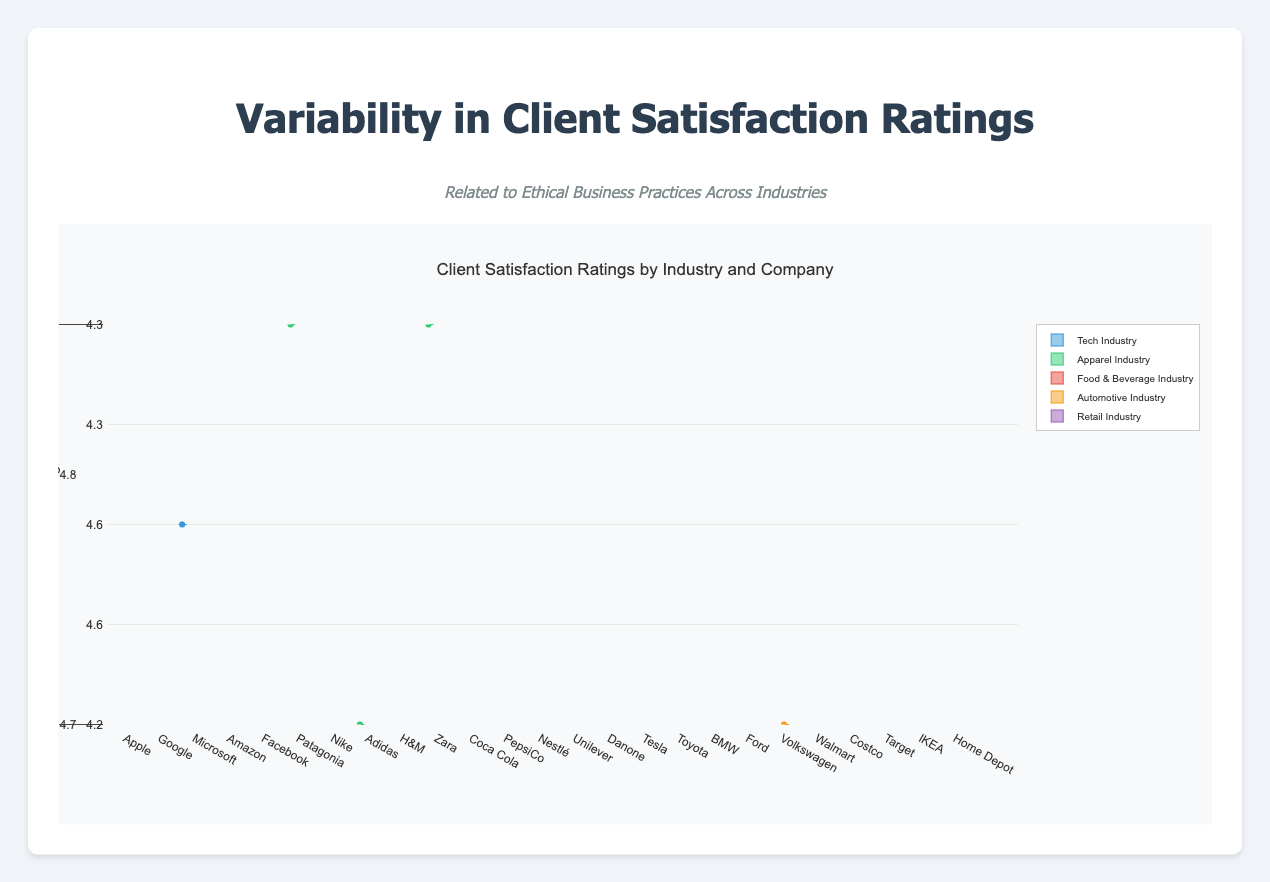What is the title of the plot? The title of the plot is located at the top and indicates the main subject of the visualization.
Answer: Client Satisfaction Ratings by Industry and Company Which industry has the highest median client satisfaction rating? To determine which industry has the highest median, look at the median line (middle line) in the boxes and compare the medians across industries.
Answer: Tech Industry Which company in the Tech Industry has the most consistent client satisfaction ratings? Consistency can be assessed by the spread, or interquartile range (IQR), of the boxplot. The company with the smallest IQR has the most consistent ratings.
Answer: Apple Compare the median satisfaction ratings between Tesla and Toyota in the Automotive Industry. Identify the median line within the boxes of Tesla and Toyota. Compare which line is higher on the satisfaction rating axis.
Answer: Tesla has a higher median satisfaction rating than Toyota Which company in the Food & Beverage Industry shows the highest client satisfaction ratings? Look for the tallest median line within the Food & Beverage Industry's box plots.
Answer: Danone What is the range of satisfaction ratings for Patagonia in the Apparel Industry? The range is the difference between the maximum and minimum values represented by the whiskers of Patagonia's box plot.
Answer: 4.7 to 4.9 Which industry shows the greatest variability in client satisfaction ratings? Variability can be assessed by comparing the overall height of the whiskers (the range from minimum to maximum) across industries.
Answer: Retail Industry What is the interquartile range (IQR) for Amazon in the Tech Industry? The IQR is the difference between the 75th percentile (upper edge of the box) and the 25th percentile (lower edge of the box). Identify the upper and lower edges and calculate the difference.
Answer: 0.3 Compare the client satisfaction ratings of Coca Cola and PepsiCo in the Food & Beverage Industry. Compare both the central tendency (medians) and spread (IQR) of the box plots for Coca Cola and PepsiCo.
Answer: PepsiCo has a slightly higher median, but both have similar spreads Which company in the Retail Industry has the lowest median client satisfaction rating? Identify the median line in the boxes for each company in the Retail Industry and find the lowest one.
Answer: Walmart 